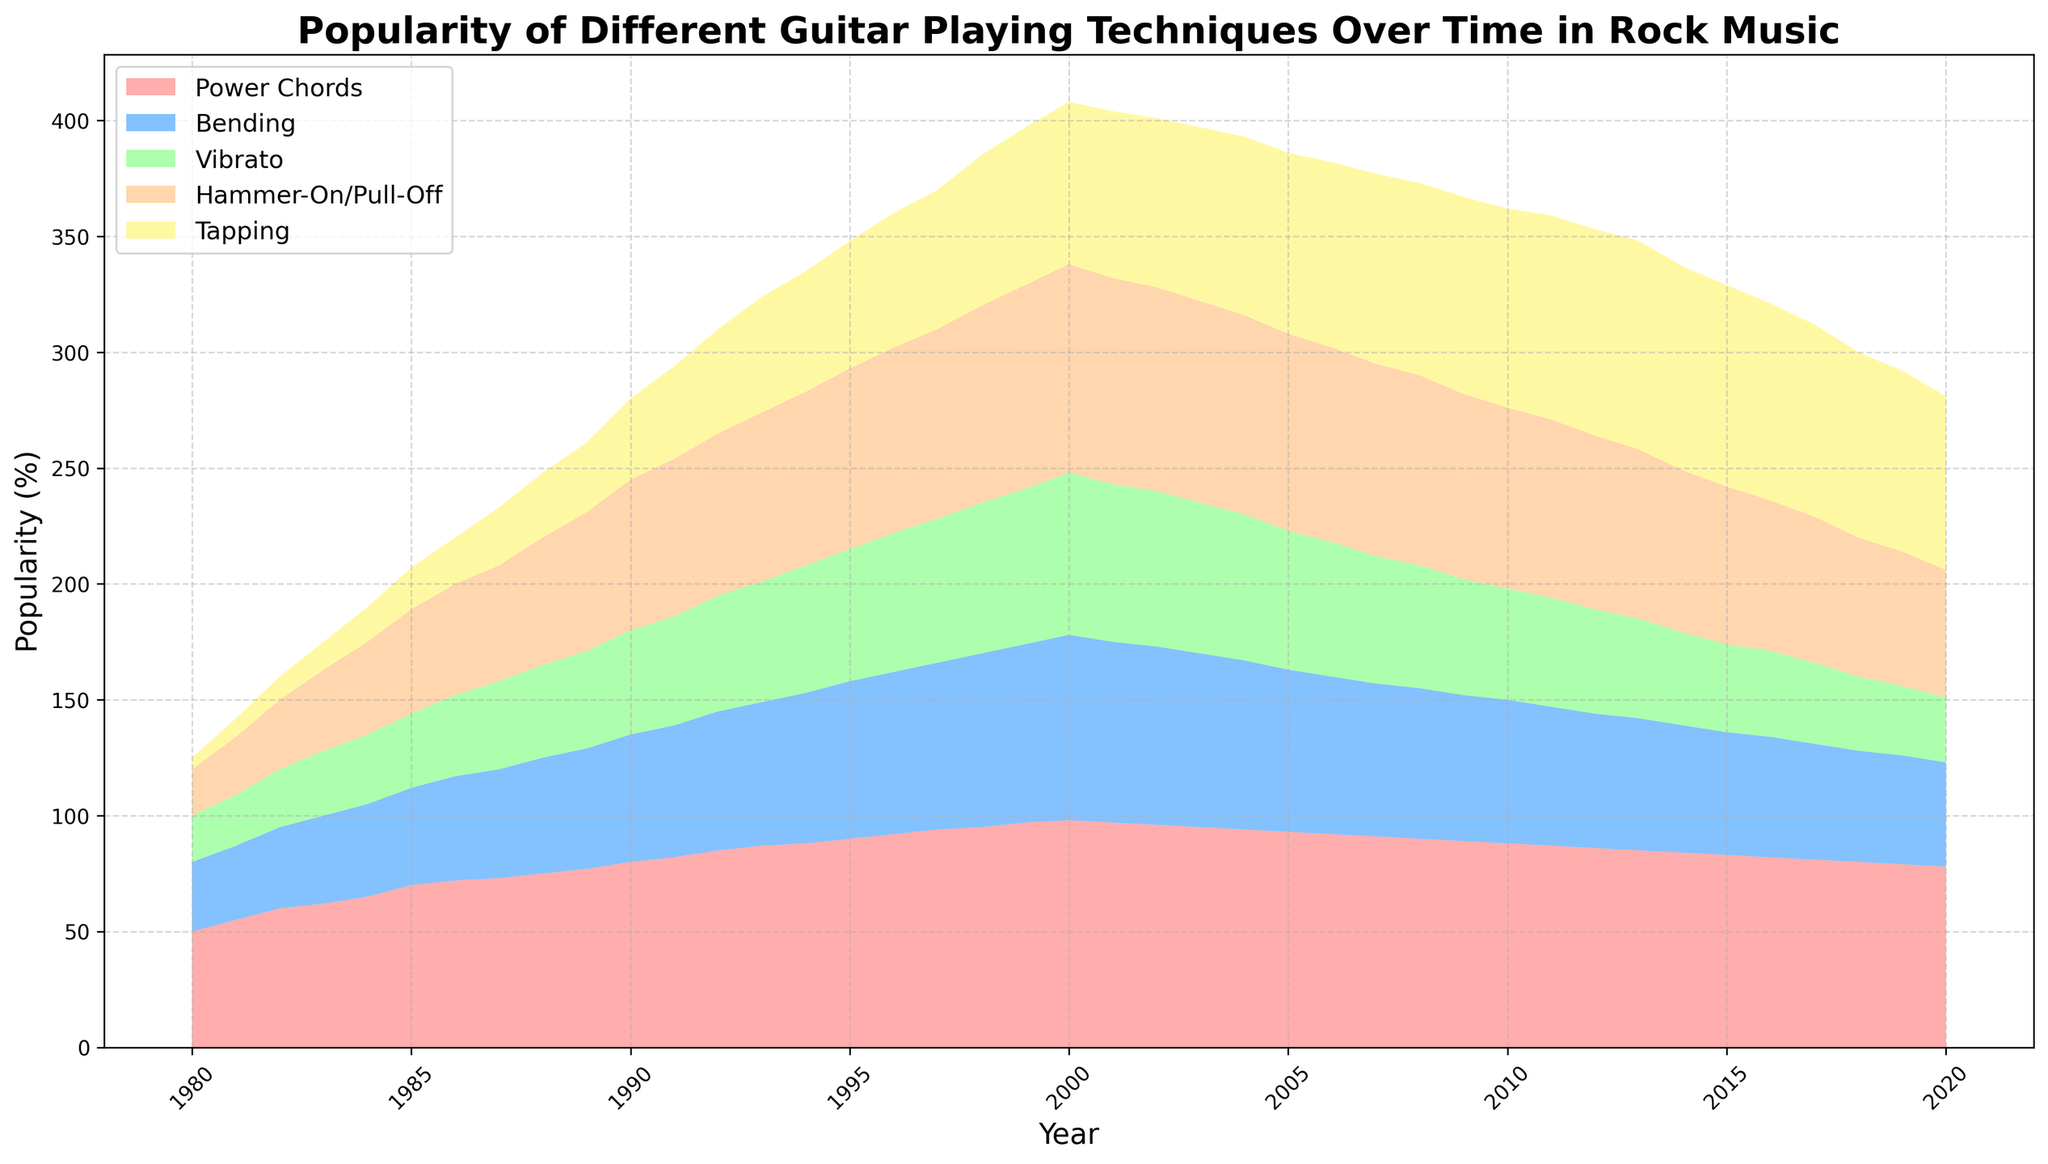What guitar playing technique was the most popular in 1990? Observe the section of the plot corresponding to 1990 and identify the largest area. The largest area is represented by the section for Power Chords.
Answer: Power Chords How did the popularity of Bending change between 1985 and 1995? Observe the Bending section in 1985 and 1995 in the plot. In 1985, the popularity is around 42%, and in 1995, it is about 68%. The popularity increased over this period.
Answer: Increased What trend do you observe for the Tapping technique after 2000? Look at the area representing Tapping from 2000 onwards. The popularity of Tapping increases slightly until around 2012 and then shows a gradual decline.
Answer: Increased initially, then declined In 1983, which two techniques combined had an approximately equal popularity to Power Chords? Observe the areas for 1983. Power Chords have a popularity of around 62%. Bending has about 38%, and Vibrato has about 28%. Summing Bending and Vibrato gives around 66%, close to Power Chords.
Answer: Bending and Vibrato What was the difference in popularity between Hammer-On/Pull-Off and Tapping in 1986? In 1986, observe the areas specifically. Hammer-On/Pull-Off has a popularity of about 48%, and Tapping is at 20%. The difference is 48% - 20% = 28%.
Answer: 28% Which technique saw the highest growth in popularity from 1980 to 2000? By comparing the starting and ending points, it is evident that Hammer-On/Pull-Off grew substantially from 20% to 90%.
Answer: Hammer-On/Pull-Off How was the popularity of Vibrato different in 2000 compared to 1990? Identify the segments for Vibrato in 1990 and 2000. In 1990, the popularity is around 45%, and in 2000, it is around 70%. The popularity increased by 25%.
Answer: Increased What is the combined popularity of Bending, Vibrato, and Tapping in 2010? Sum the popularity values for Bending (62%), Vibrato (48%), and Tapping (86%) for 2010. This gives 62 + 48 + 86 = 196%.
Answer: 196% By how much did the popularity of Power Chords decrease from its peak in 2000 to 2010? Observe the plot for Power Chords in 2000 and 2010. Peak in 2000 is 98%, and in 2010 it is 88%. The decrease is 98% - 88% = 10%.
Answer: 10% Which technique consistently shows a declining trend after 2000? Look at all the techniques after 2000. Both Power Chords and Bending show some decline, but Power Chords show a consistent decline.
Answer: Power Chords 